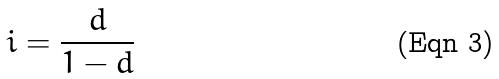Convert formula to latex. <formula><loc_0><loc_0><loc_500><loc_500>i = \frac { d } { 1 - d }</formula> 